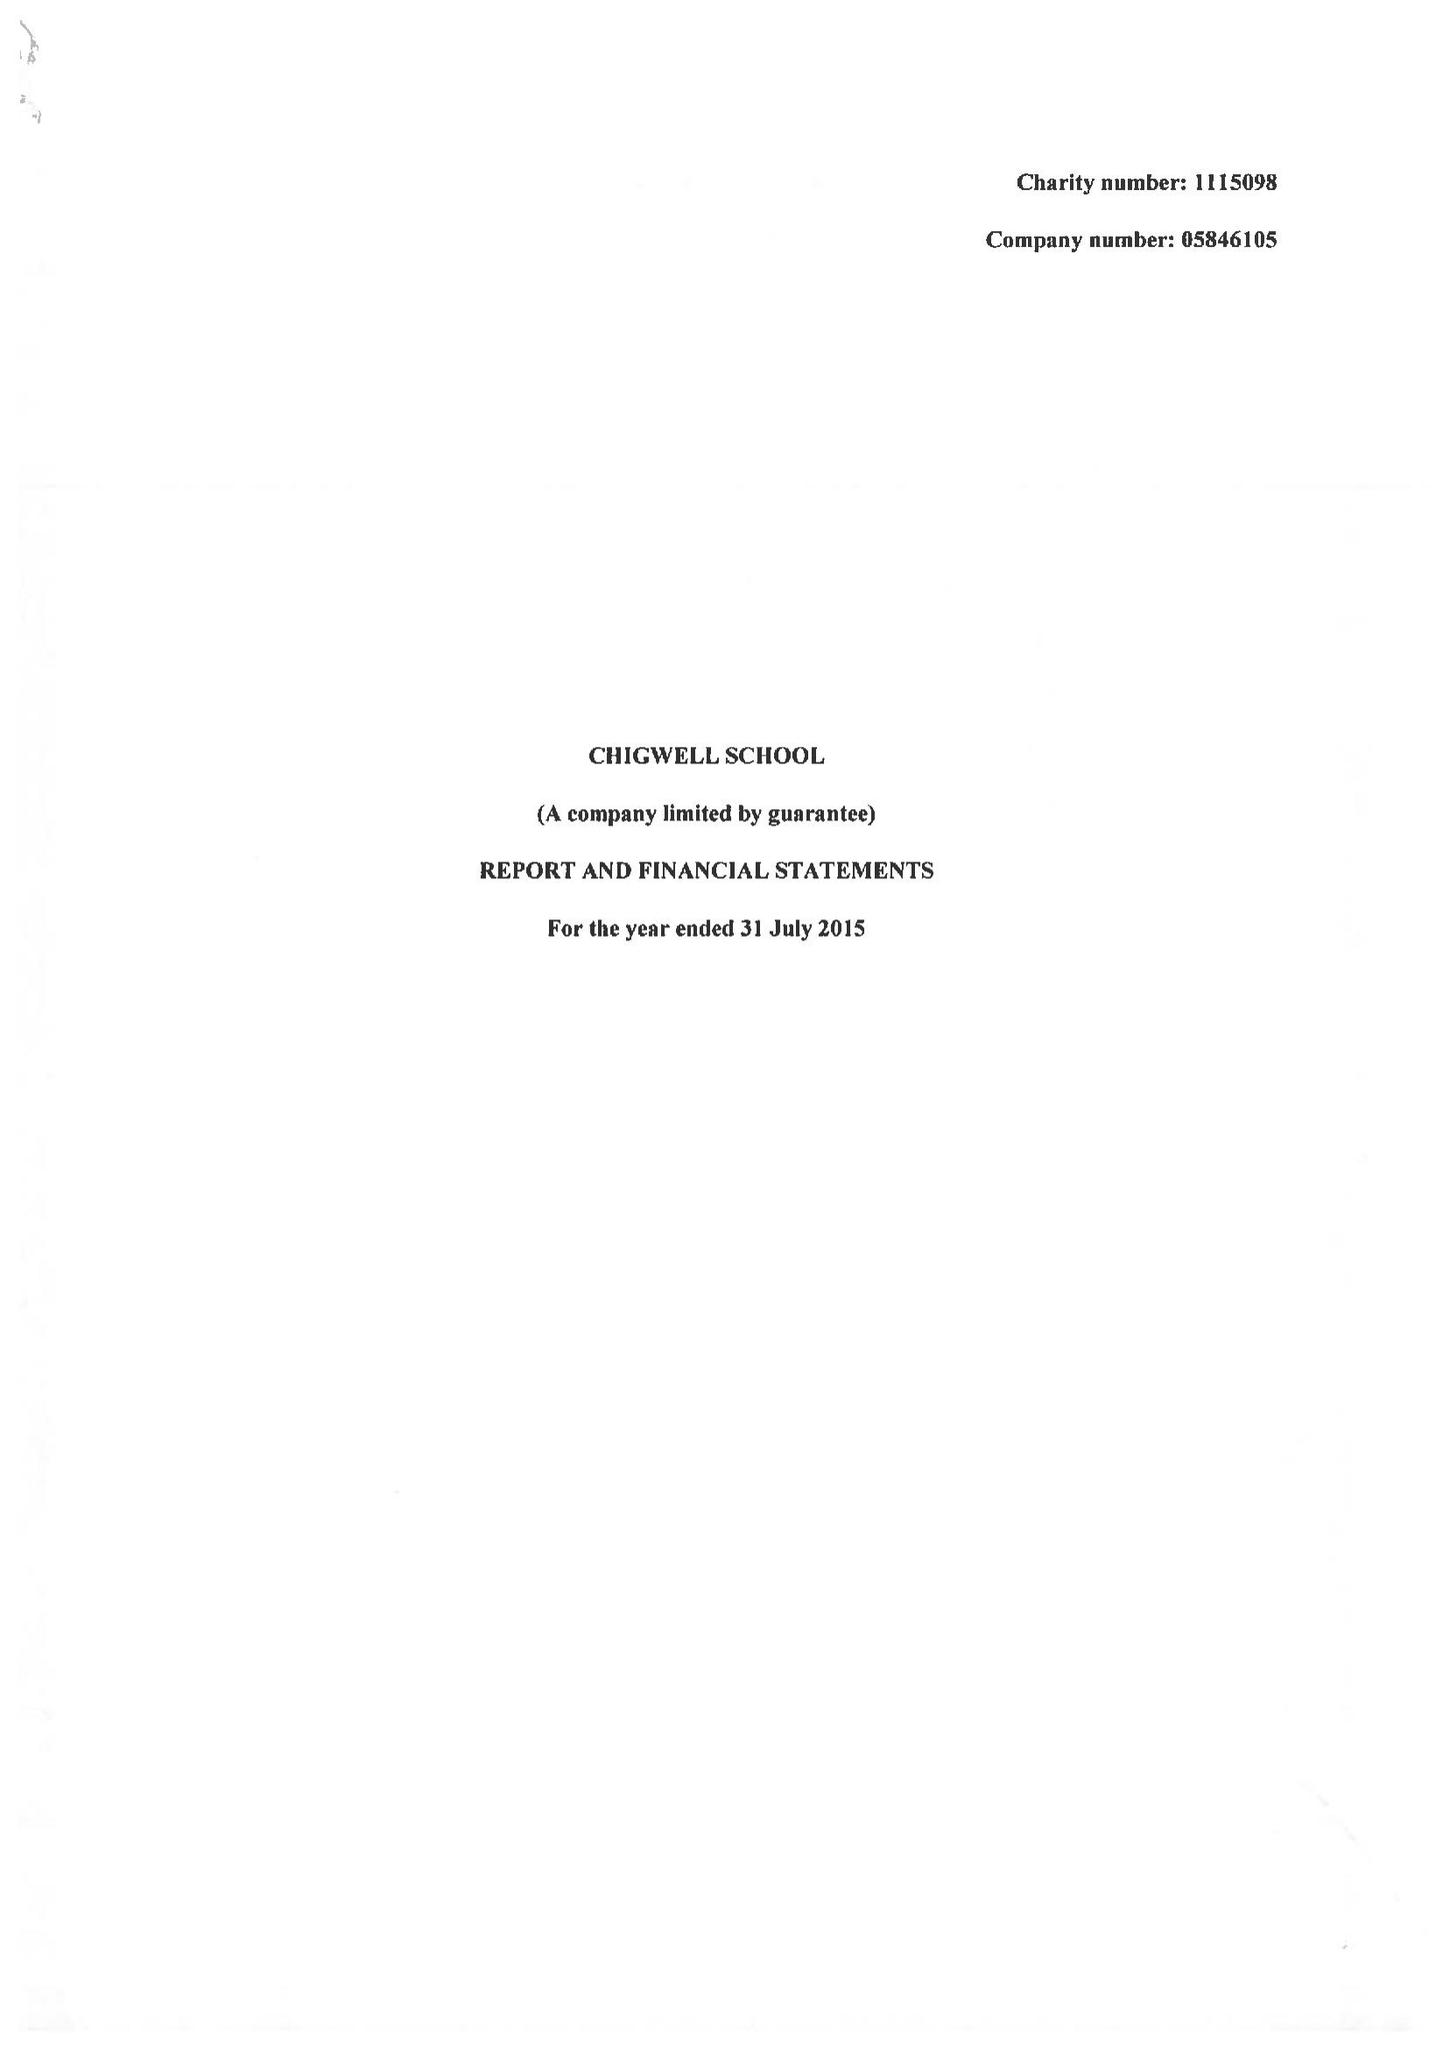What is the value for the report_date?
Answer the question using a single word or phrase. 2015-07-31 